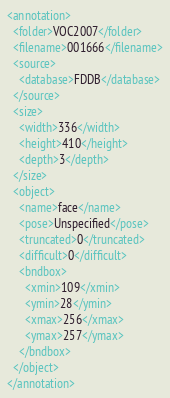<code> <loc_0><loc_0><loc_500><loc_500><_XML_><annotation>
  <folder>VOC2007</folder>
  <filename>001666</filename>
  <source>
    <database>FDDB</database>
  </source>
  <size>
    <width>336</width>
    <height>410</height>
    <depth>3</depth>
  </size>
  <object>
    <name>face</name>
    <pose>Unspecified</pose>
    <truncated>0</truncated>
    <difficult>0</difficult>
    <bndbox>
      <xmin>109</xmin>
      <ymin>28</ymin>
      <xmax>256</xmax>
      <ymax>257</ymax>
    </bndbox>
  </object>
</annotation>
</code> 